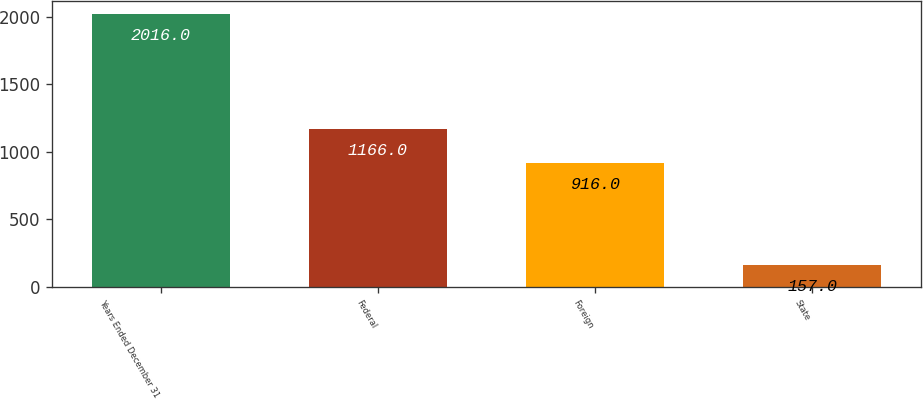Convert chart. <chart><loc_0><loc_0><loc_500><loc_500><bar_chart><fcel>Years Ended December 31<fcel>Federal<fcel>Foreign<fcel>State<nl><fcel>2016<fcel>1166<fcel>916<fcel>157<nl></chart> 